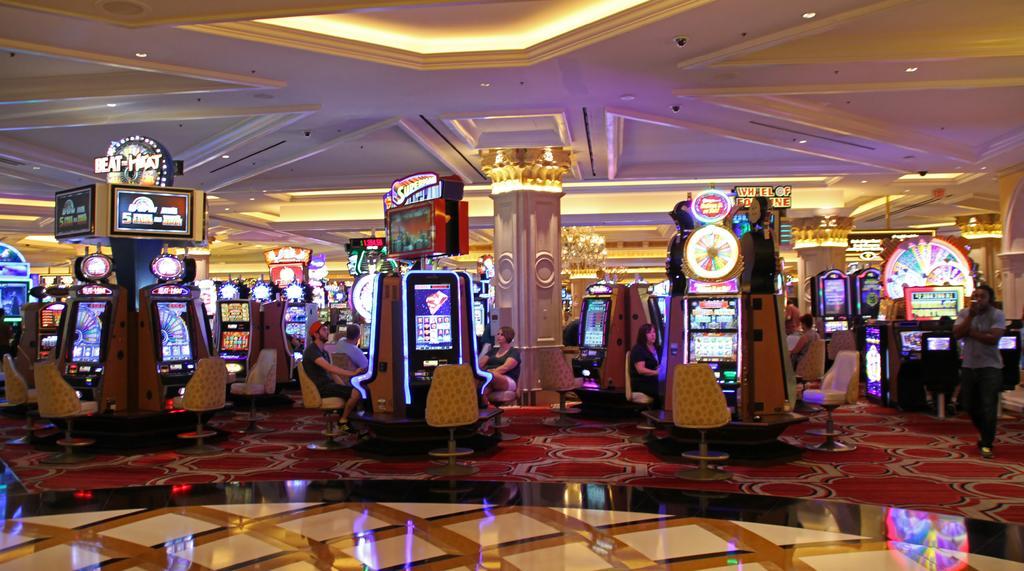Describe this image in one or two sentences. In this picture we can see a person holding an object with his hand, standing on the floor, some people are sitting on chairs, machines, posters, pillars, chandelier and in the background we can see the lights, ceiling. 